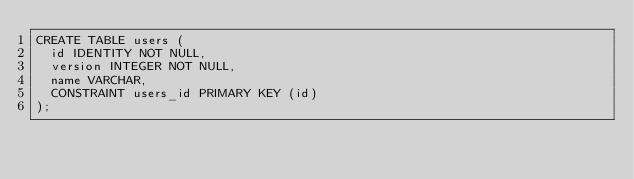<code> <loc_0><loc_0><loc_500><loc_500><_SQL_>CREATE TABLE users (
  id IDENTITY NOT NULL,
  version INTEGER NOT NULL,
  name VARCHAR,
  CONSTRAINT users_id PRIMARY KEY (id)
);</code> 